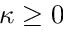Convert formula to latex. <formula><loc_0><loc_0><loc_500><loc_500>\kappa \geq 0</formula> 